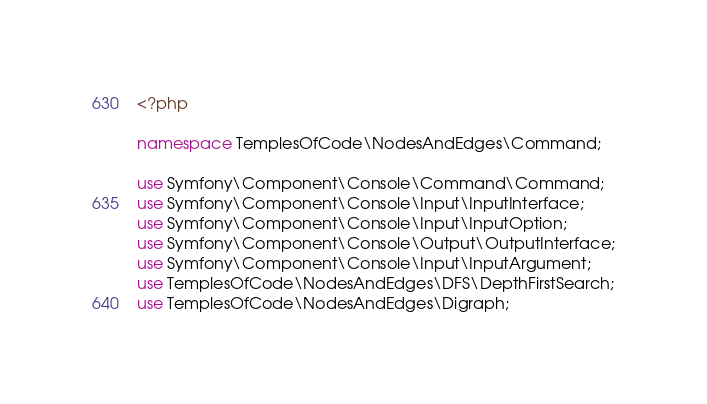Convert code to text. <code><loc_0><loc_0><loc_500><loc_500><_PHP_><?php

namespace TemplesOfCode\NodesAndEdges\Command;

use Symfony\Component\Console\Command\Command;
use Symfony\Component\Console\Input\InputInterface;
use Symfony\Component\Console\Input\InputOption;
use Symfony\Component\Console\Output\OutputInterface;
use Symfony\Component\Console\Input\InputArgument;
use TemplesOfCode\NodesAndEdges\DFS\DepthFirstSearch;
use TemplesOfCode\NodesAndEdges\Digraph;</code> 